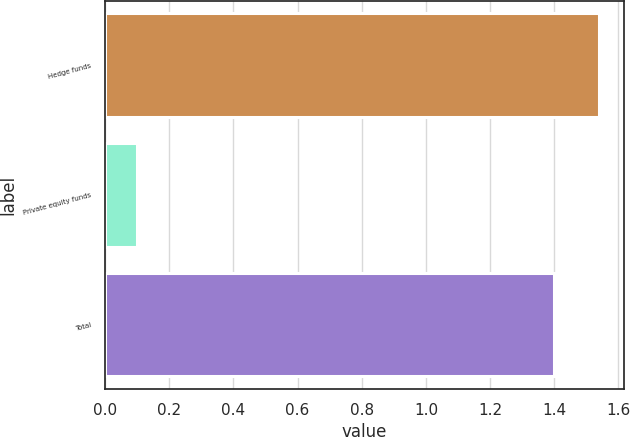Convert chart. <chart><loc_0><loc_0><loc_500><loc_500><bar_chart><fcel>Hedge funds<fcel>Private equity funds<fcel>Total<nl><fcel>1.54<fcel>0.1<fcel>1.4<nl></chart> 